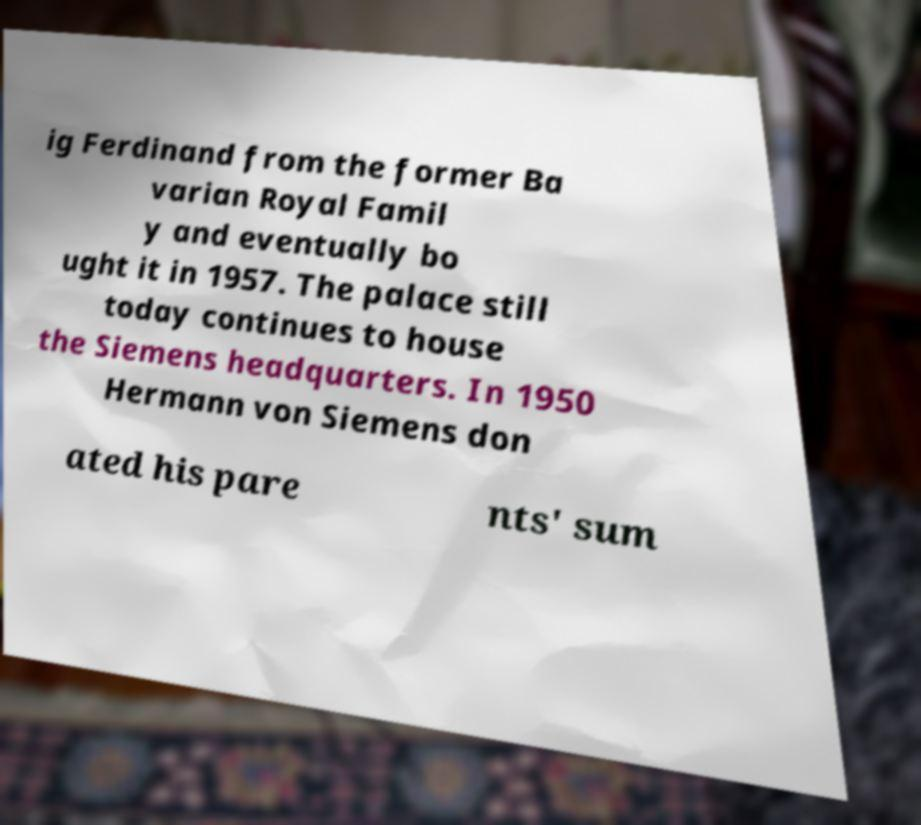There's text embedded in this image that I need extracted. Can you transcribe it verbatim? ig Ferdinand from the former Ba varian Royal Famil y and eventually bo ught it in 1957. The palace still today continues to house the Siemens headquarters. In 1950 Hermann von Siemens don ated his pare nts' sum 